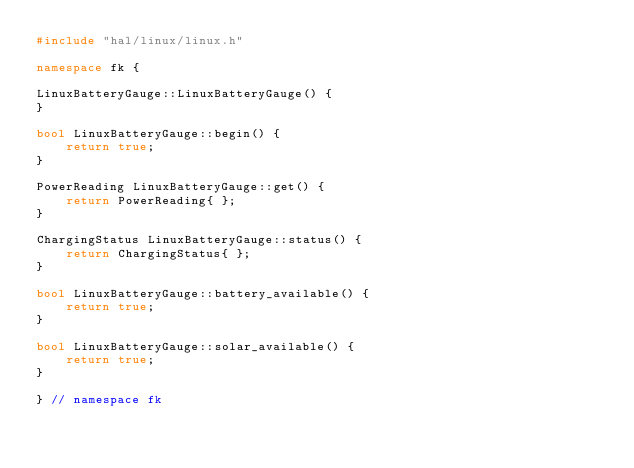<code> <loc_0><loc_0><loc_500><loc_500><_C++_>#include "hal/linux/linux.h"

namespace fk {

LinuxBatteryGauge::LinuxBatteryGauge() {
}

bool LinuxBatteryGauge::begin() {
    return true;
}

PowerReading LinuxBatteryGauge::get() {
    return PowerReading{ };
}

ChargingStatus LinuxBatteryGauge::status() {
    return ChargingStatus{ };
}

bool LinuxBatteryGauge::battery_available() {
    return true;
}

bool LinuxBatteryGauge::solar_available() {
    return true;
}

} // namespace fk
</code> 